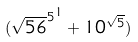<formula> <loc_0><loc_0><loc_500><loc_500>( { \sqrt { 5 6 } ^ { 5 } } ^ { 1 } + 1 0 ^ { \sqrt { 5 } } )</formula> 